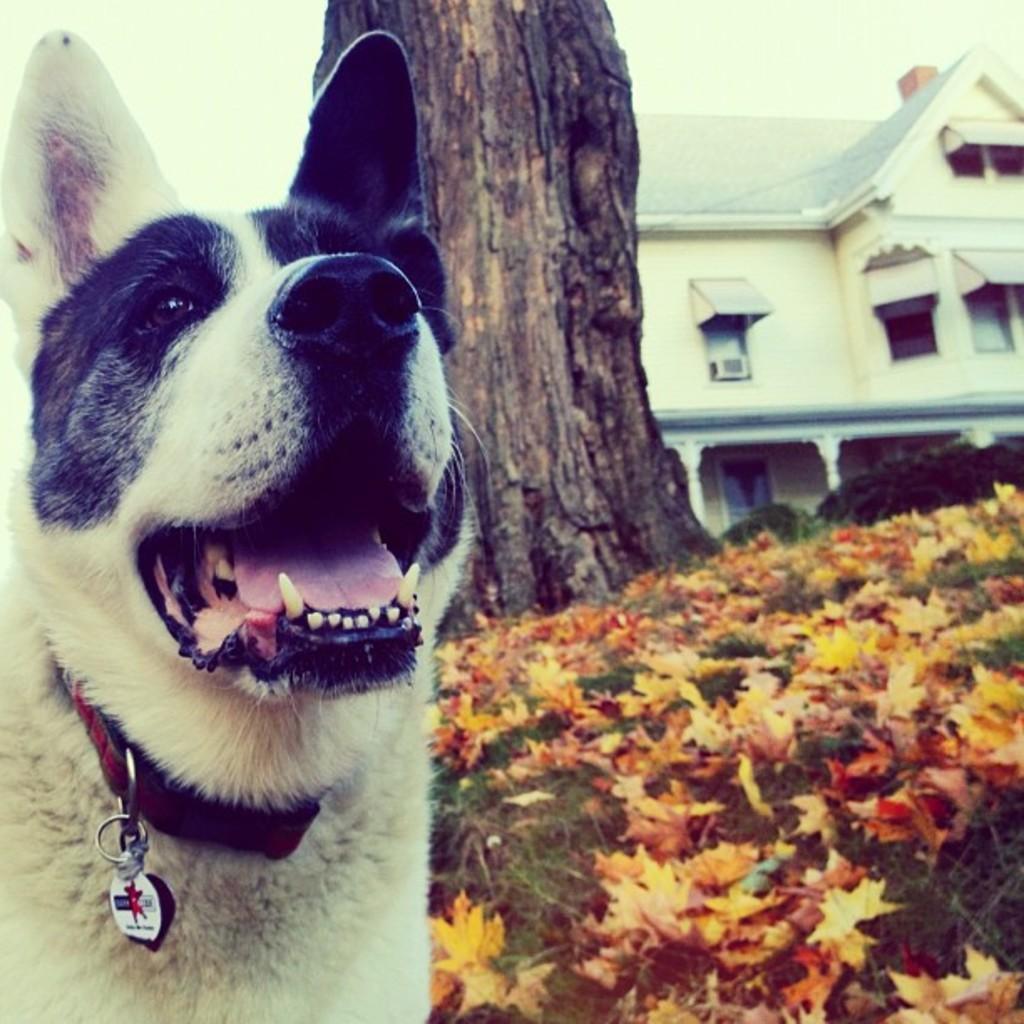Could you give a brief overview of what you see in this image? There is a dog on the left side of this image , and we can see flower plants, bark of a tree and a building on the right side of this image. 